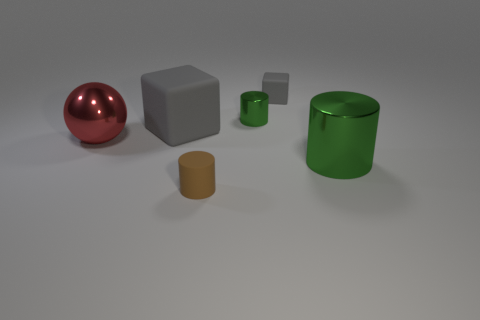Subtract all blue balls. How many green cylinders are left? 2 Subtract all metal cylinders. How many cylinders are left? 1 Add 4 tiny things. How many objects exist? 10 Subtract all blocks. How many objects are left? 4 Subtract all metallic balls. Subtract all tiny brown objects. How many objects are left? 4 Add 5 matte cylinders. How many matte cylinders are left? 6 Add 6 red things. How many red things exist? 7 Subtract 0 blue cubes. How many objects are left? 6 Subtract all red cylinders. Subtract all brown cubes. How many cylinders are left? 3 